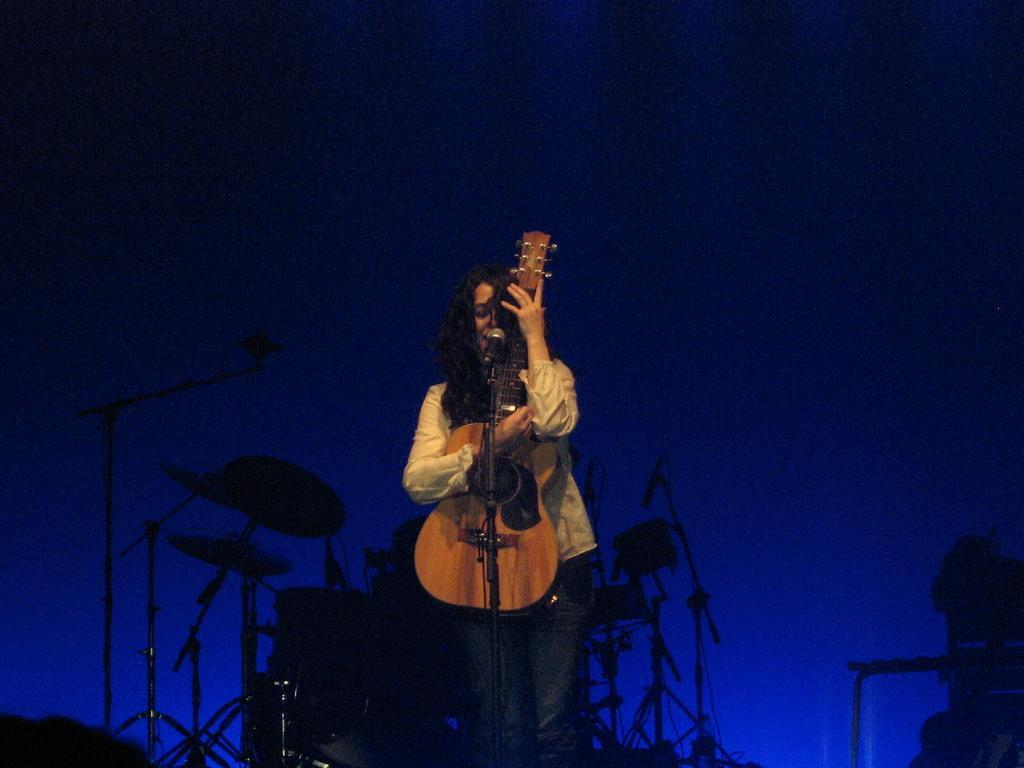Can you describe this image briefly? This picture shows a woman Standing and holding a guitar in her hand and speaking with the help of a microphone in front of her and we see drums on her back and we see a blue colour background 